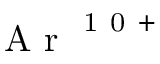Convert formula to latex. <formula><loc_0><loc_0><loc_500><loc_500>A r ^ { 1 0 + }</formula> 